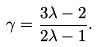<formula> <loc_0><loc_0><loc_500><loc_500>\gamma = \frac { 3 \lambda - 2 } { 2 \lambda - 1 } .</formula> 